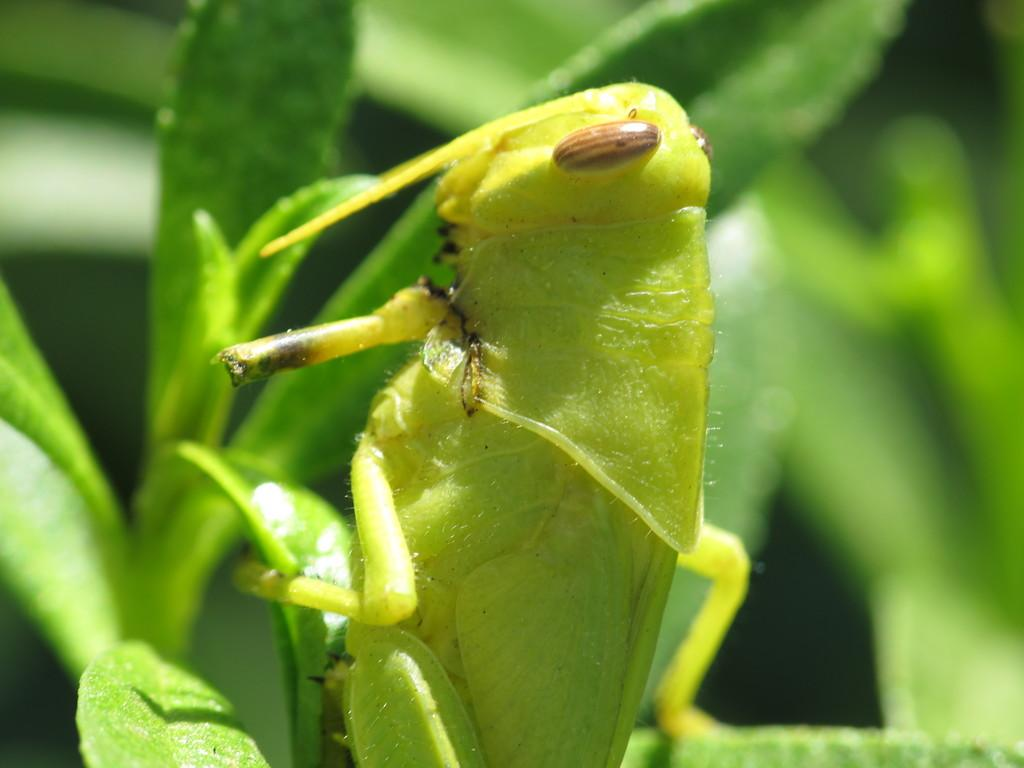What type of animal is in the image? There is a grasshopper in the image. What is the grasshopper standing on? The grasshopper is standing on a plant. What type of pollution can be seen in the image? There is no pollution present in the image; it features a grasshopper standing on a plant. What type of tray is visible in the image? There is no tray present in the image. 